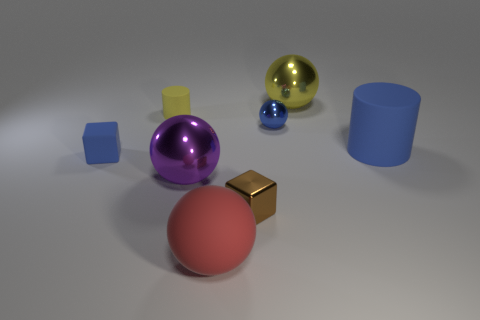Add 2 small red rubber spheres. How many objects exist? 10 Subtract all cylinders. How many objects are left? 6 Subtract 0 gray blocks. How many objects are left? 8 Subtract all red cylinders. Subtract all blue cubes. How many objects are left? 7 Add 7 small rubber objects. How many small rubber objects are left? 9 Add 6 brown shiny balls. How many brown shiny balls exist? 6 